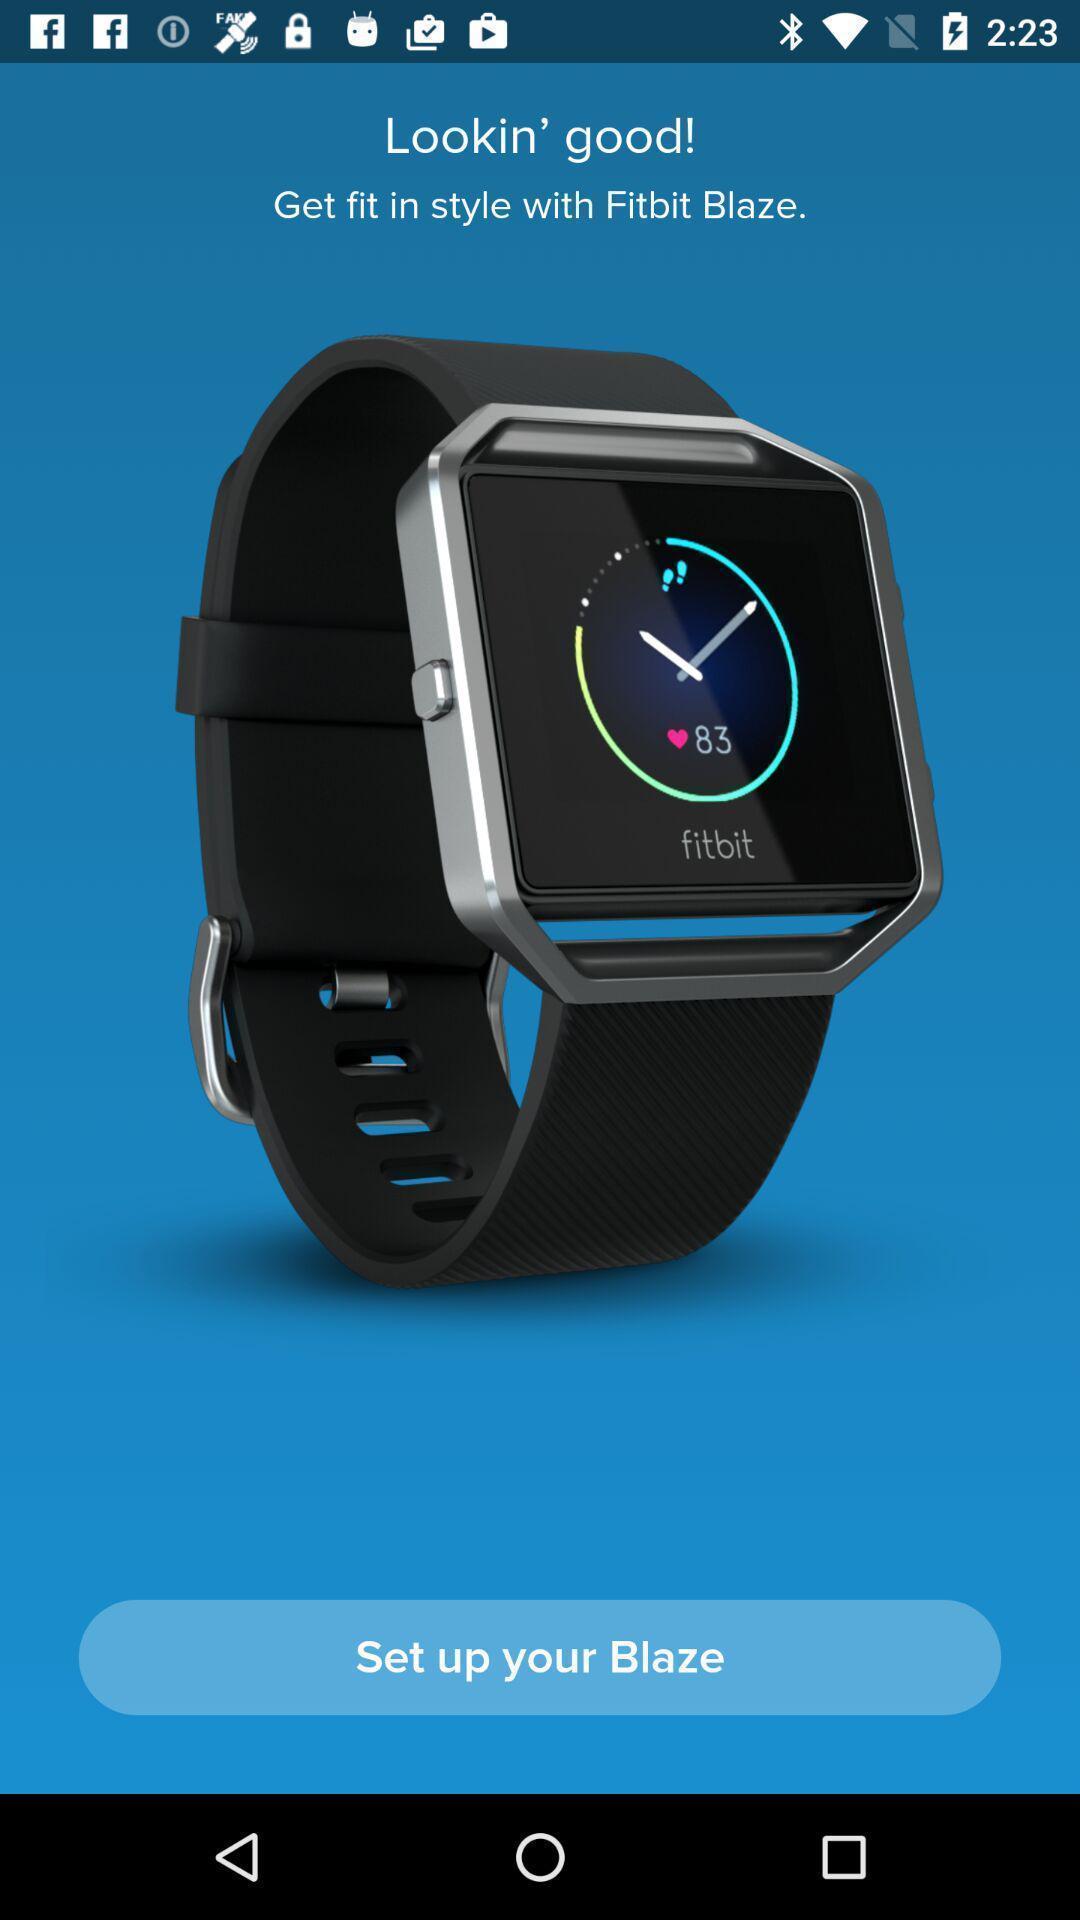Describe the key features of this screenshot. Step tracking page of a tracking app. 